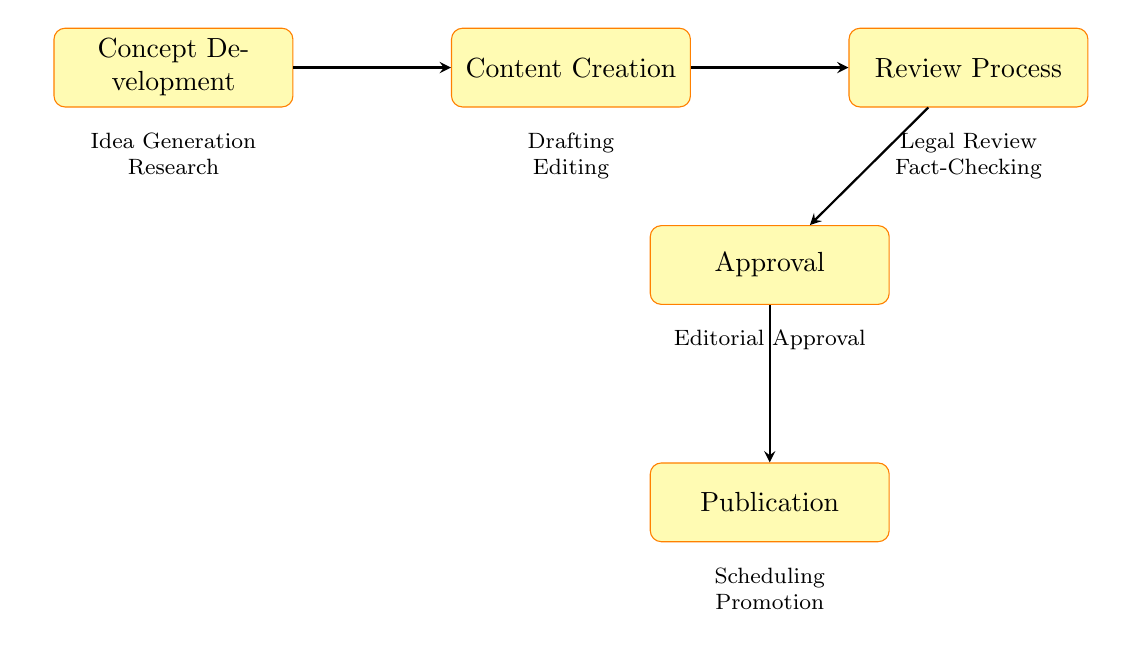What are the two stages in Concept Development? The diagram shows that "Concept Development" includes two stages: "Idea Generation" and "Research." These stages are listed directly below the "Concept Development" node.
Answer: Idea Generation, Research How many main stages are there in the editorial workflow? By counting the main nodes in the diagram, we can see there are five primary stages: "Concept Development," "Content Creation," "Review Process," "Approval," and "Publication."
Answer: Five What is the final step before publication in the workflow? The diagram indicates that "Approval" is the step that directly precedes "Publication." The arrows connecting the nodes show the flow of the process.
Answer: Approval Which stage follows Fact-Checking? Looking at the flow of the diagram, "Fact-Checking" is part of the "Review Process," and the next stage indicated is "Approval." Therefore, "Approval" follows "Fact-Checking."
Answer: Approval What are the two tasks involved in the Publication stage? The diagram clearly lists two tasks below the "Publication" node: "Publication Scheduling" and "Promotion." These tasks help illustrate the activities involved in the publication process.
Answer: Publication Scheduling, Promotion What type of review is conducted after content creation? Referring to the diagram, "Legal Review" follows after the "Content Creation" stage. This indicates that it is the type of review performed.
Answer: Legal Review What node connects Content Creation to Publication? According to the arrows shown in the diagram, the node "Approval" connects "Content Creation" to "Publication." It serves as the intermediary stage in the workflow.
Answer: Approval How is information verified in the workflow? The diagram includes a node labeled "Fact-Checking" as part of the "Review Process." This implies that information verification occurs at this stage in the workflow.
Answer: Fact-Checking What happens after Editorial Approval? Following the "Approval" stage, the diagram indicates that the next step is "Publication," which means after editorial approval, the content is published.
Answer: Publication 